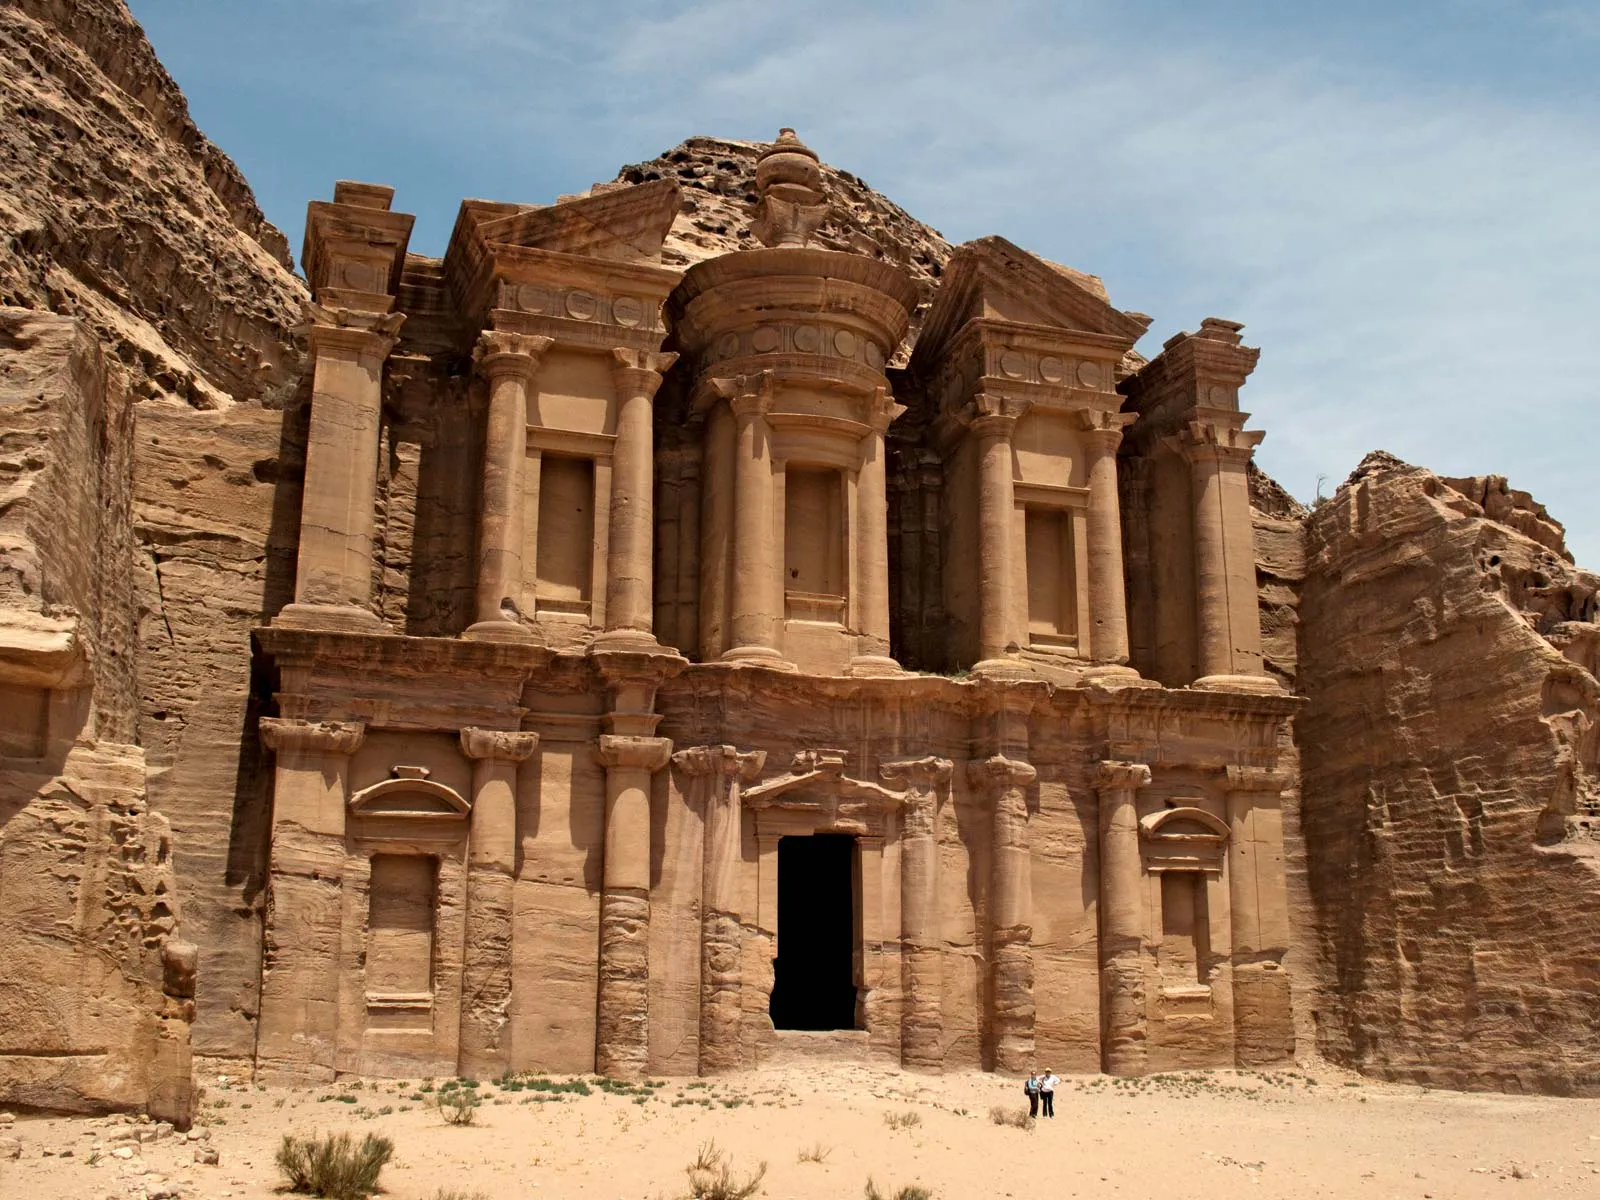Can you explain the architectural significance of the Monastery's design? The architecture of the Monastery in Petra is a striking example of the Nabatean ability to blend their indigenous architectural styles with Hellenistic influences. The design features a broad, deep facade carved out of the rock with iconic columns and a large doorway reminiscent of Roman temples. The presence of Nabatean crow-step elements and Greek-style pilasters showcases a hybrid architectural vocabulary. This design not only served aesthetic purposes but also demonstrated the religious and social importance of the structure, intended to impress visitors and devotees alike. 